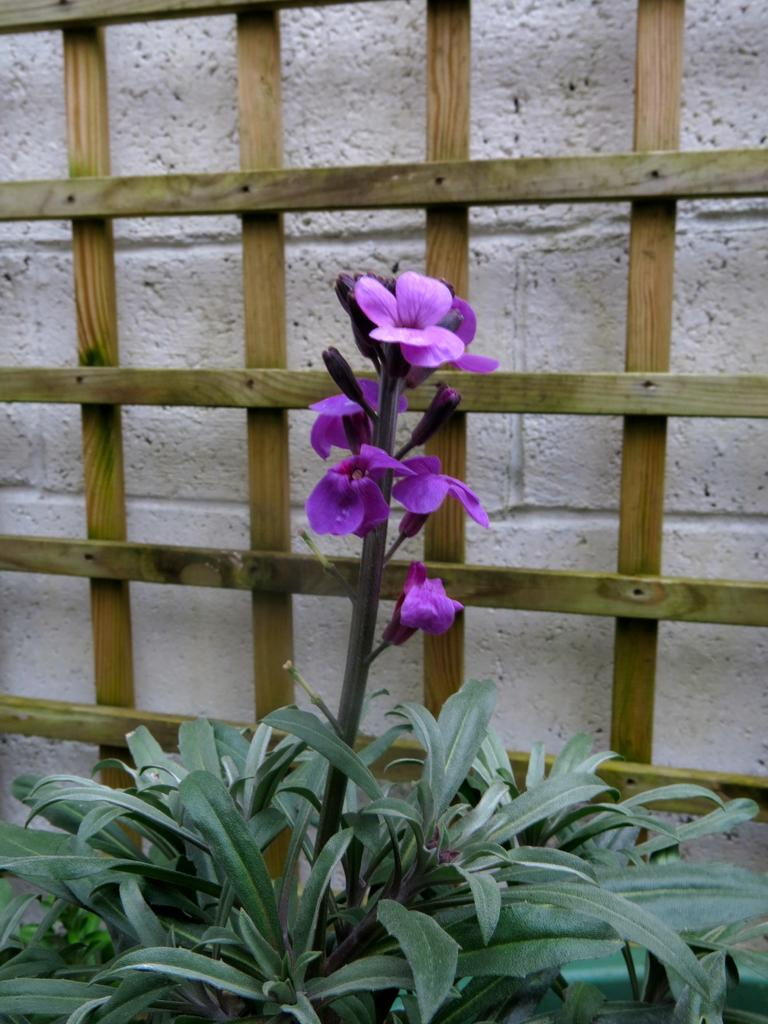What type of vegetation is in the front of the image? There are plants in the front of the image. Can you describe the flower in the image? Yes, there is a flower in the image. What can be seen in the background of the image? There is a wooden stand and a wall in the background of the image. What type of sponge is being used to water the plants in the image? There is no sponge visible in the image, and it is not mentioned that the plants are being watered. Can you tell me the age of the grandfather in the image? There is no grandfather present in the image. 